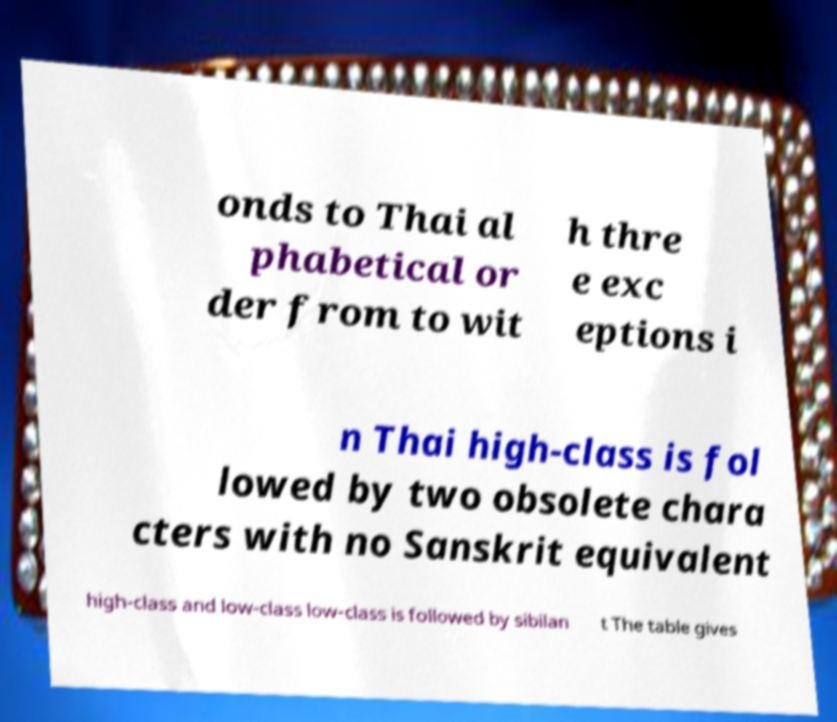Could you assist in decoding the text presented in this image and type it out clearly? onds to Thai al phabetical or der from to wit h thre e exc eptions i n Thai high-class is fol lowed by two obsolete chara cters with no Sanskrit equivalent high-class and low-class low-class is followed by sibilan t The table gives 